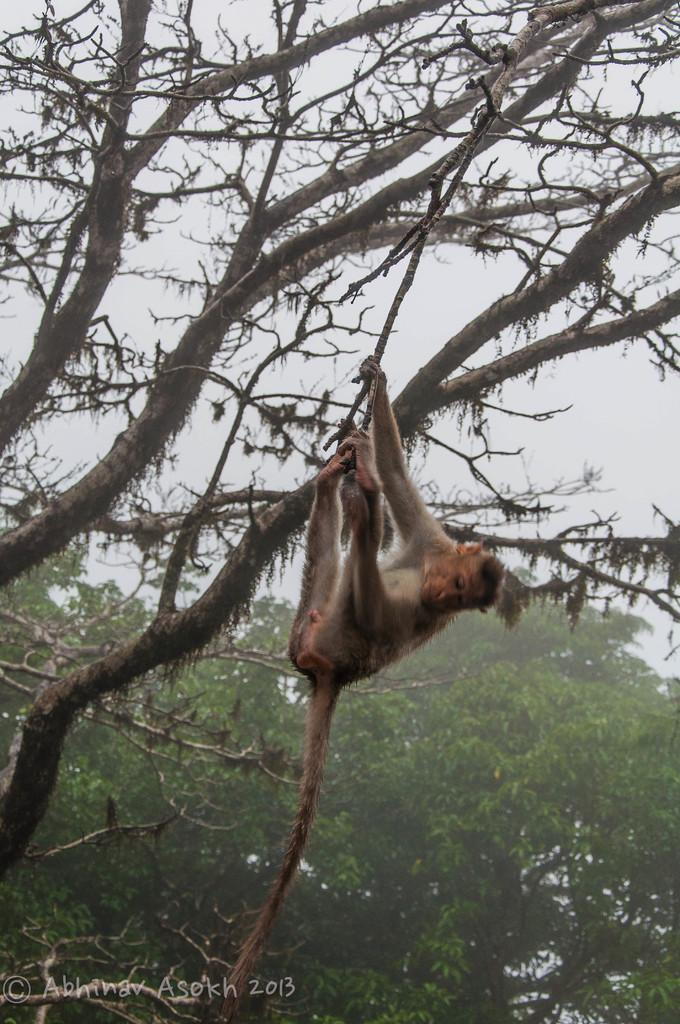What animal is present in the picture? There is a monkey in the picture. What type of natural environment is depicted in the picture? There are trees in the picture, suggesting a forest or jungle setting. What can be seen at the top of the picture? The sky is visible at the top of the picture. Where is the text located in the picture? The text is at the left bottom of the picture. How does the monkey gain knowledge by touching the ocean in the picture? There is no ocean present in the picture, and the monkey is not shown touching anything. 